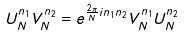Convert formula to latex. <formula><loc_0><loc_0><loc_500><loc_500>U _ { N } ^ { n _ { 1 } } V _ { N } ^ { n _ { 2 } } = e ^ { \frac { 2 \pi } { N } i n _ { 1 } n _ { 2 } } V _ { N } ^ { n _ { 1 } } U _ { N } ^ { n _ { 2 } }</formula> 